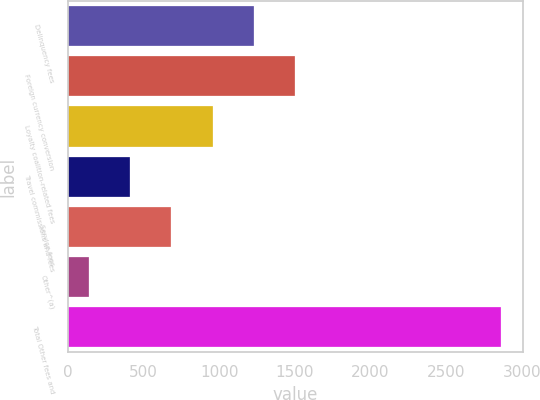Convert chart. <chart><loc_0><loc_0><loc_500><loc_500><bar_chart><fcel>Delinquency fees<fcel>Foreign currency conversion<fcel>Loyalty coalition-related fees<fcel>Travel commissions and fees<fcel>Service fees<fcel>Other^(a)<fcel>Total Other fees and<nl><fcel>1228.6<fcel>1501.5<fcel>955.7<fcel>409.9<fcel>682.8<fcel>137<fcel>2866<nl></chart> 